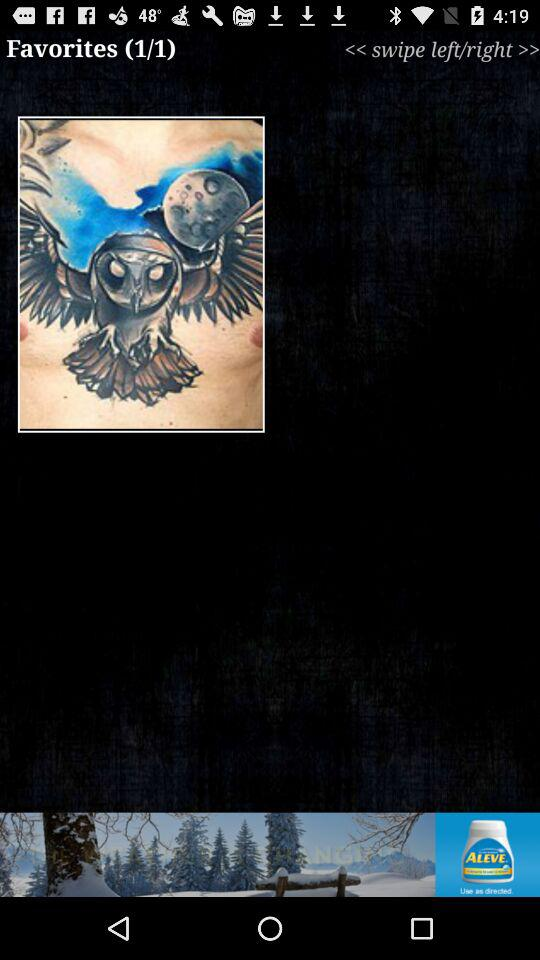What favorite item is the user currently on? The user is currently on the first favorite item. 